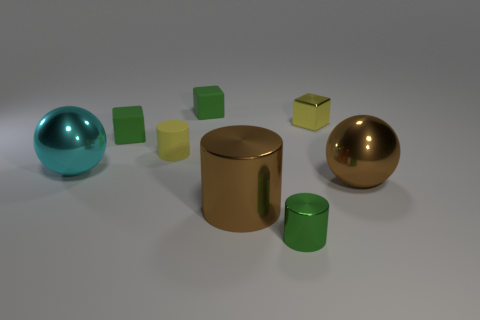Subtract all yellow spheres. How many green cubes are left? 2 Add 2 large brown blocks. How many objects exist? 10 Subtract all cylinders. How many objects are left? 5 Subtract all small green metallic objects. Subtract all large metallic cylinders. How many objects are left? 6 Add 2 tiny green cylinders. How many tiny green cylinders are left? 3 Add 3 green rubber things. How many green rubber things exist? 5 Subtract 0 cyan cylinders. How many objects are left? 8 